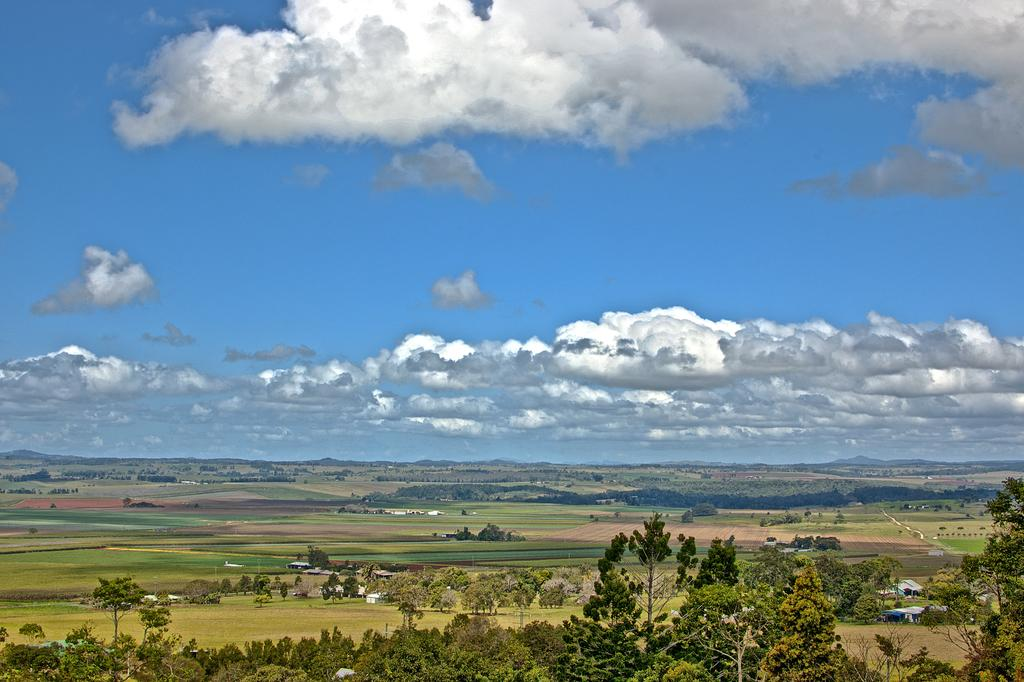What type of vegetation is present at the bottom of the image? There are trees and grass at the bottom of the image. What structures can be seen at the bottom of the image? There are houses at the bottom of the image. What is visible at the top of the image? The sky is visible at the top of the image. What is the condition of the sky in the image? The sky is cloudy in the image. How many jellyfish are swimming in the sky in the image? There are no jellyfish present in the image; it features trees, grass, houses, and a cloudy sky. What type of authority is depicted in the image? There is no authority figure or representation of authority present in the image. 